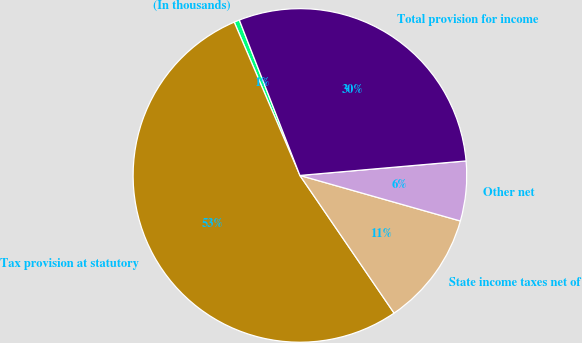Convert chart. <chart><loc_0><loc_0><loc_500><loc_500><pie_chart><fcel>(In thousands)<fcel>Tax provision at statutory<fcel>State income taxes net of<fcel>Other net<fcel>Total provision for income<nl><fcel>0.53%<fcel>53.11%<fcel>11.05%<fcel>5.79%<fcel>29.53%<nl></chart> 